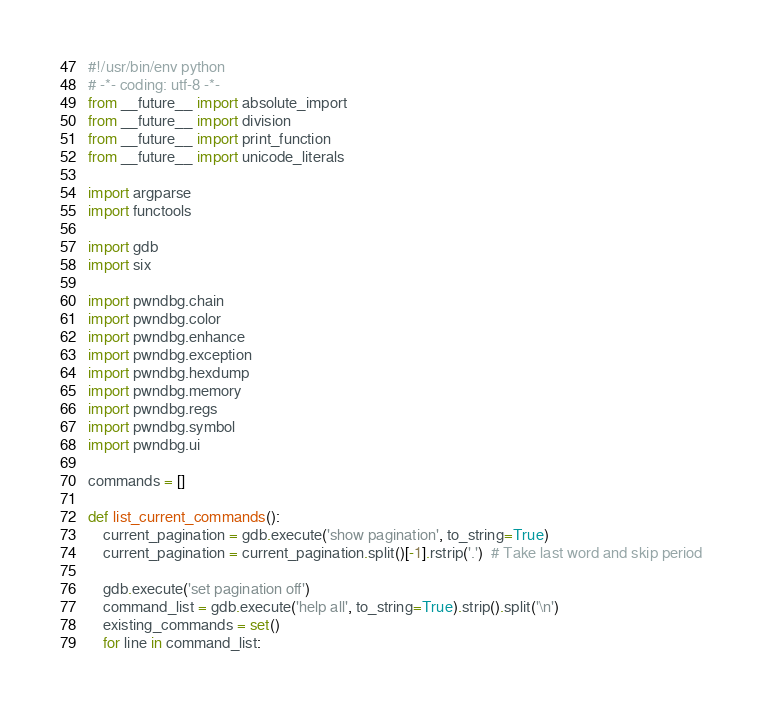<code> <loc_0><loc_0><loc_500><loc_500><_Python_>#!/usr/bin/env python
# -*- coding: utf-8 -*-
from __future__ import absolute_import
from __future__ import division
from __future__ import print_function
from __future__ import unicode_literals

import argparse
import functools

import gdb
import six

import pwndbg.chain
import pwndbg.color
import pwndbg.enhance
import pwndbg.exception
import pwndbg.hexdump
import pwndbg.memory
import pwndbg.regs
import pwndbg.symbol
import pwndbg.ui

commands = []

def list_current_commands():
    current_pagination = gdb.execute('show pagination', to_string=True)
    current_pagination = current_pagination.split()[-1].rstrip('.')  # Take last word and skip period

    gdb.execute('set pagination off')
    command_list = gdb.execute('help all', to_string=True).strip().split('\n')
    existing_commands = set()
    for line in command_list:</code> 